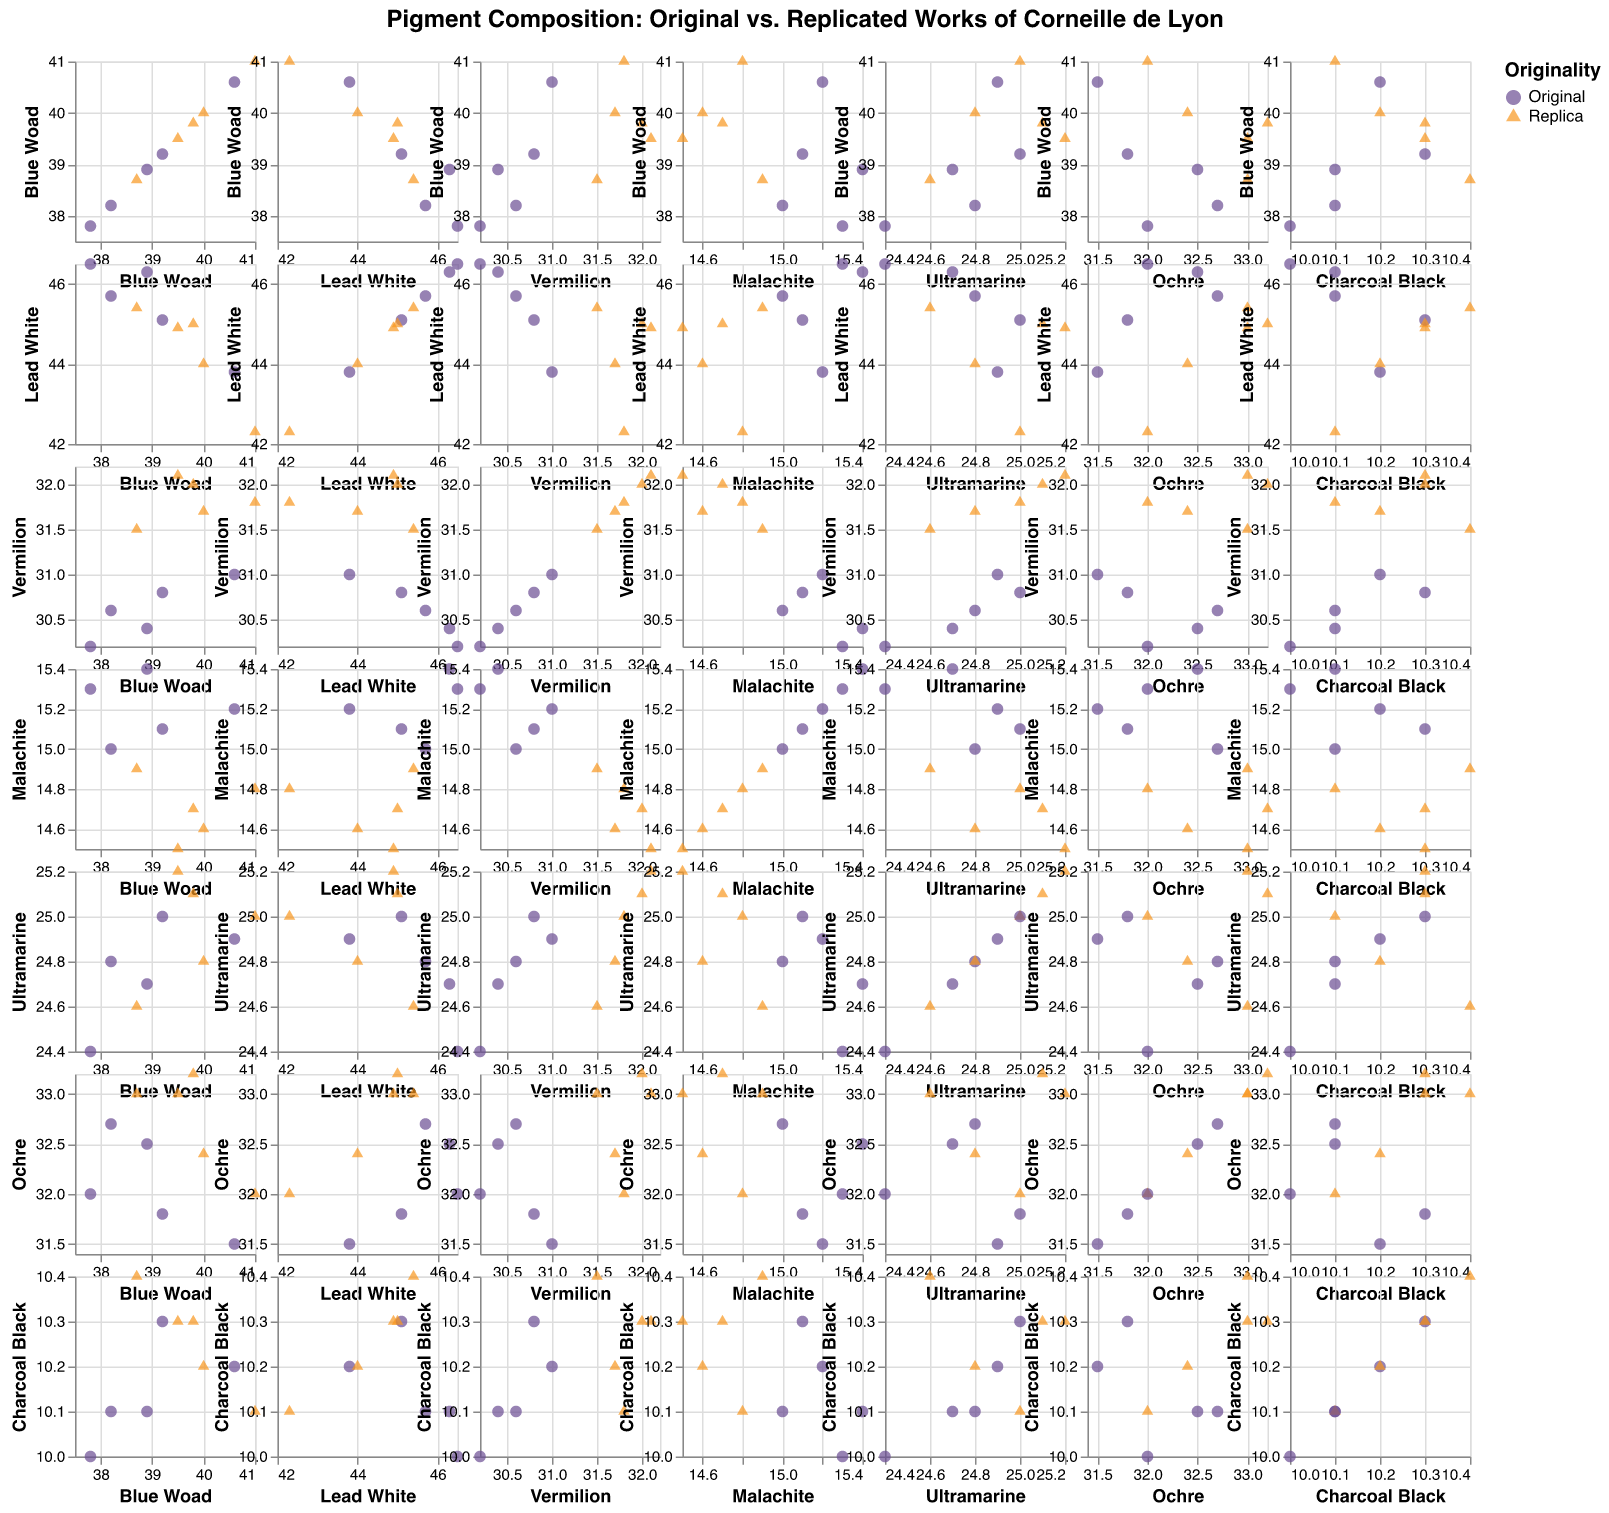What is the title of the figure? The title is located at the top center of the figure. It reads "Pigment Composition: Original vs. Replicated Works of Corneille de Lyon."
Answer: Pigment Composition: Original vs. Replicated Works of Corneille de Lyon How many pigment variables are being compared in the matrix? Each cell in the SPLOM represents a comparison between two pigment variables. There are seven pigment variables compared in both the row and column: Blue Woad, Lead White, Vermilion, Malachite, Ultramarine, Ochre, and Charcoal Black.
Answer: Seven What different shapes are used to distinguish the Original from the Replica works in the plot? By examining the legend and the points within the scatter plots, we can see that circles represent Original works, and triangles represent Replica works.
Answer: Circles and triangles What's the difference in Blue Woad composition between the Original and Replica works on average? We first calculate the average Blue Woad value for Original works (38.2, 40.6, 37.8, 39.2, 38.9) and the average for Replica works (39.5, 41.0, 38.7, 40.0, 39.8). Averages are (38.2+40.6+37.8+39.2+38.9)/5 = 38.94 for Original, and (39.5+41.0+38.7+40.0+39.8)/5 = 39.8 for Replica. The difference is 39.8 - 38.94.
Answer: 0.86 In which pigment composition does the variability (difference between maximum and minimum values) of Original works appear the greatest? We need to compute the range (maximum - minimum) for each pigment in the Original works: Blue Woad (40.6 - 37.8 = 2.8), Lead White (46.5 - 43.8 = 2.7), Vermilion (31.0 - 30.2 = 0.8), Malachite (15.4 - 15.0 = 0.4), Ultramarine (25.0 - 24.4 = 0.6), Ochre (32.7 - 31.5 = 1.2), Charcoal Black (10.3 - 10.0 = 0.3). Thus, the greatest variability is in Blue Woad.
Answer: Blue Woad Are there any pairs of pigments that show a noticeable correlation in the Replica works? To identify noticeable correlations, we look for diagonal trends within the scatter plots specific to Replica works (triangles). Upon examining the SPLOM, the pair Lead White vs. Ochre appears to have a positive correlation, indicating that as one increases, so does the other.
Answer: Lead White and Ochre Which pigment shows the least difference in its mean composition between Original and Replica works? Calculate mean for each pigment, for both Original and Replica, and then find the smallest difference: Blue Woad (38.94-39.8=0.86), Lead White (45.48-44.32=1.16), Vermilion (30.6-31.82=1.22), Malachite (15.2-14.7=0.5), Ultramarine (24.76-24.94=0.18), Ochre (32.1-32.72=0.62), Charcoal Black (10.14-10.26=0.12). Ultramarine has the smallest difference.
Answer: Ultramarine 